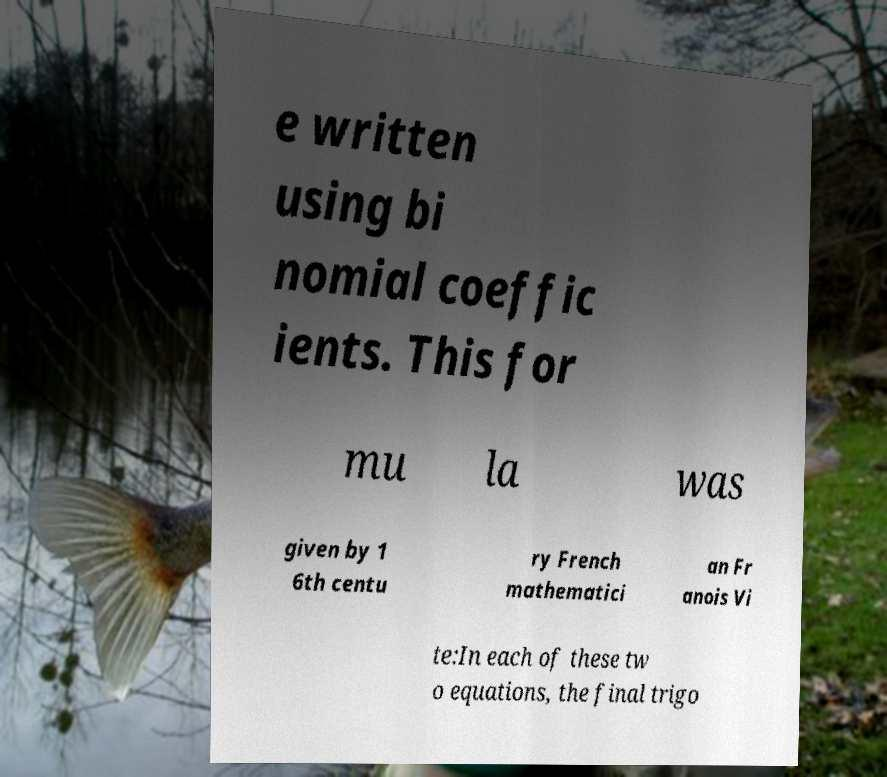Can you accurately transcribe the text from the provided image for me? e written using bi nomial coeffic ients. This for mu la was given by 1 6th centu ry French mathematici an Fr anois Vi te:In each of these tw o equations, the final trigo 